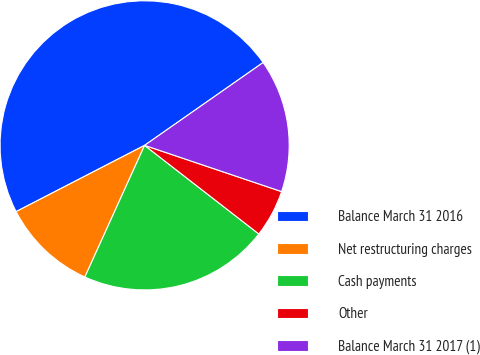Convert chart. <chart><loc_0><loc_0><loc_500><loc_500><pie_chart><fcel>Balance March 31 2016<fcel>Net restructuring charges<fcel>Cash payments<fcel>Other<fcel>Balance March 31 2017 (1)<nl><fcel>47.87%<fcel>10.64%<fcel>21.28%<fcel>5.32%<fcel>14.89%<nl></chart> 